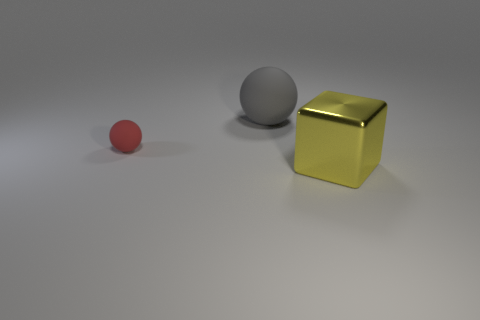Subtract all blocks. How many objects are left? 2 Subtract all red spheres. How many spheres are left? 1 Add 1 large yellow shiny balls. How many objects exist? 4 Subtract all green cylinders. How many gray spheres are left? 1 Subtract all yellow shiny objects. Subtract all purple shiny cylinders. How many objects are left? 2 Add 3 red matte things. How many red matte things are left? 4 Add 1 big shiny blocks. How many big shiny blocks exist? 2 Subtract 0 gray cylinders. How many objects are left? 3 Subtract 1 cubes. How many cubes are left? 0 Subtract all cyan balls. Subtract all yellow blocks. How many balls are left? 2 